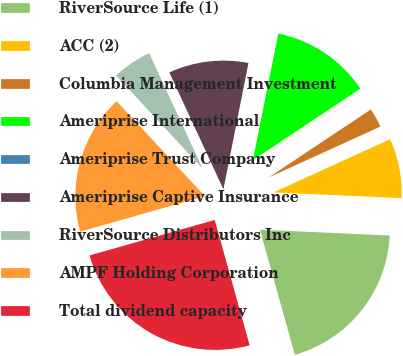Convert chart. <chart><loc_0><loc_0><loc_500><loc_500><pie_chart><fcel>RiverSource Life (1)<fcel>ACC (2)<fcel>Columbia Management Investment<fcel>Ameriprise International<fcel>Ameriprise Trust Company<fcel>Ameriprise Captive Insurance<fcel>RiverSource Distributors Inc<fcel>AMPF Holding Corporation<fcel>Total dividend capacity<nl><fcel>19.96%<fcel>7.52%<fcel>2.54%<fcel>12.49%<fcel>0.05%<fcel>10.01%<fcel>5.03%<fcel>17.47%<fcel>24.93%<nl></chart> 